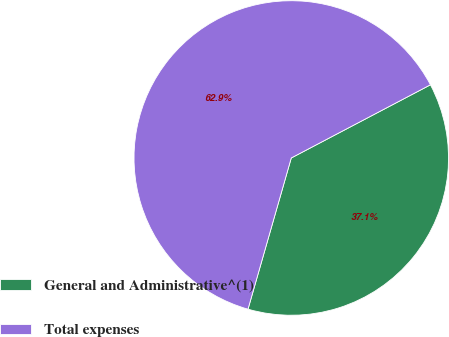Convert chart. <chart><loc_0><loc_0><loc_500><loc_500><pie_chart><fcel>General and Administrative^(1)<fcel>Total expenses<nl><fcel>37.14%<fcel>62.86%<nl></chart> 